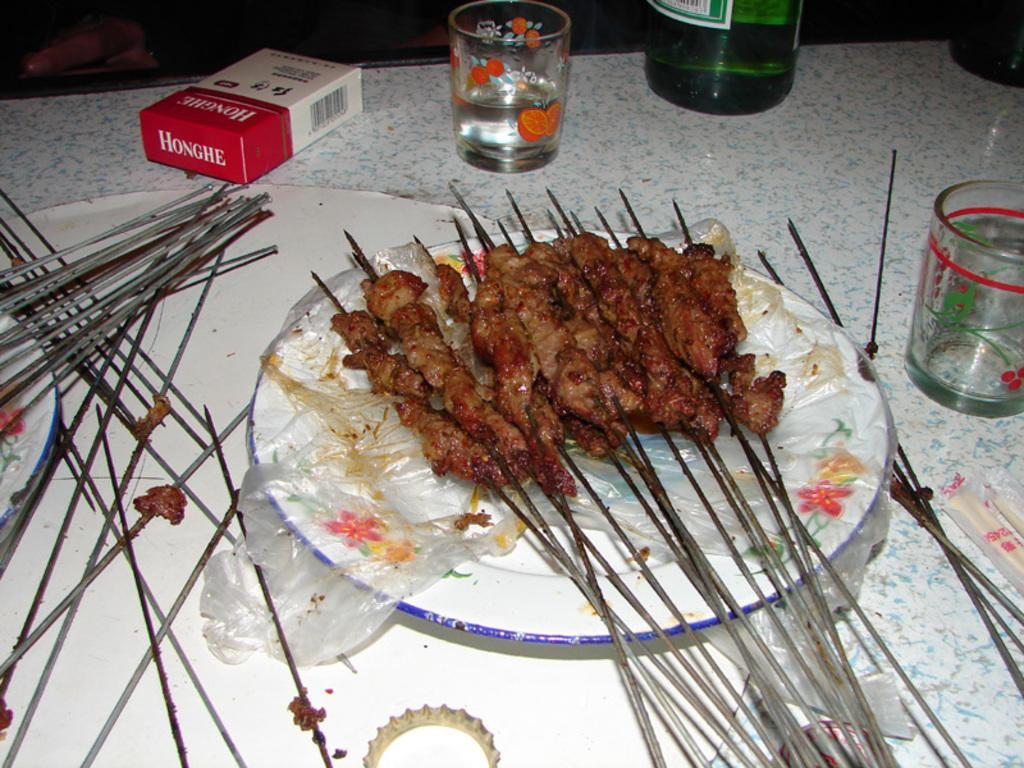What type of furniture is present in the image? There is a table in the image. What items can be seen on the table? There are eatables, drinks, a box, and other objects on the table. Can you describe the eatables on the table? Unfortunately, the facts provided do not specify the type of eatables on the table. What is the purpose of the box on the table? The purpose of the box on the table is not mentioned in the provided facts. What type of sweater is being used as a tablecloth in the image? There is no sweater present in the image, as it features a table with various items on it. 